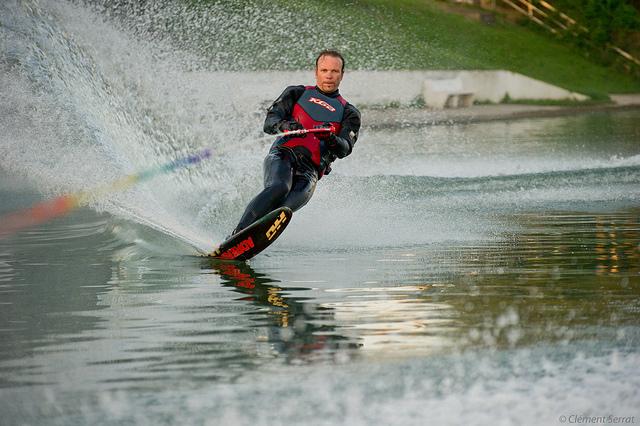Is he wearing glasses?
Quick response, please. No. What is the guy doing?
Write a very short answer. Water skiing. Does this activity require you know how to swim?
Keep it brief. Yes. 